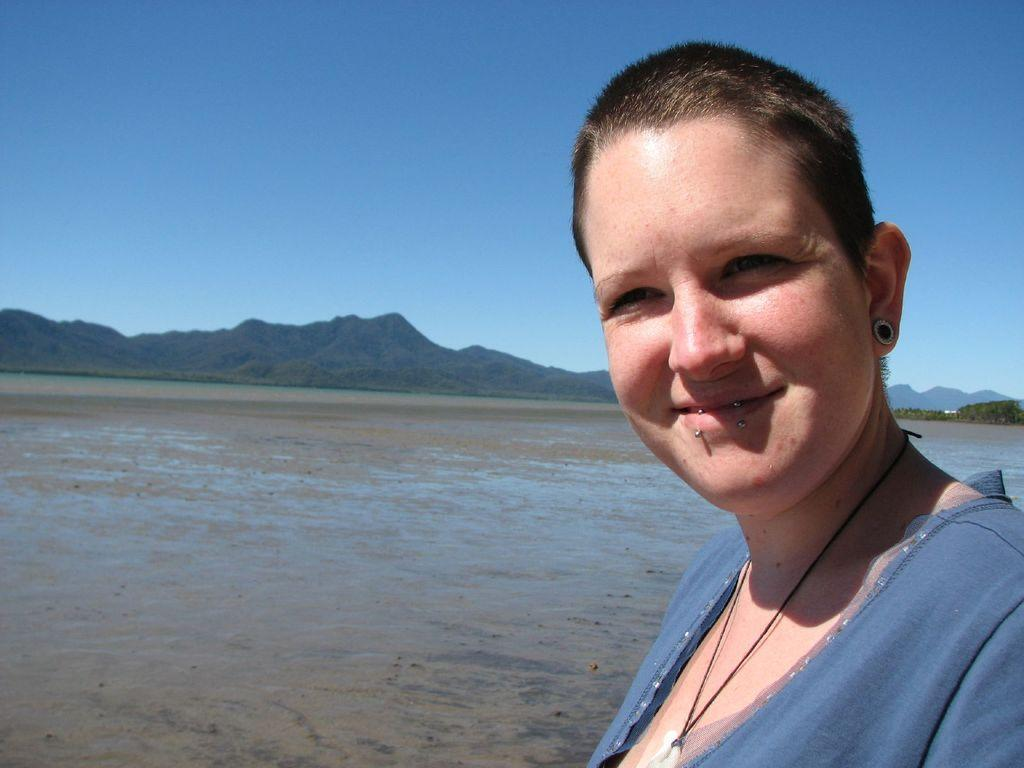Who is present in the image? There is a woman in the image. What is the woman's facial expression? The woman is smiling. What color are the clothes the woman is wearing? The woman is wearing grey clothes. What can be seen in the background of the image? There are mountains, the sky, and water visible in the background of the image. What type of pollution can be seen in the image? There is no pollution visible in the image. What kind of feast is the woman preparing in the image? There is no feast or any indication of food preparation in the image. 